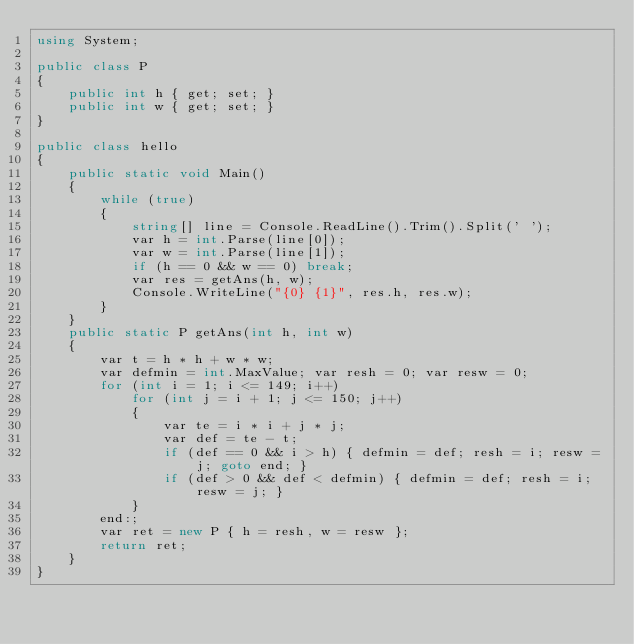Convert code to text. <code><loc_0><loc_0><loc_500><loc_500><_C#_>using System;

public class P
{
    public int h { get; set; }
    public int w { get; set; }
}

public class hello
{
    public static void Main()
    {
        while (true)
        {
            string[] line = Console.ReadLine().Trim().Split(' ');
            var h = int.Parse(line[0]);
            var w = int.Parse(line[1]);
            if (h == 0 && w == 0) break;
            var res = getAns(h, w);
            Console.WriteLine("{0} {1}", res.h, res.w);
        }
    }
    public static P getAns(int h, int w)
    {
        var t = h * h + w * w;
        var defmin = int.MaxValue; var resh = 0; var resw = 0;
        for (int i = 1; i <= 149; i++)
            for (int j = i + 1; j <= 150; j++)
            {
                var te = i * i + j * j;
                var def = te - t;
                if (def == 0 && i > h) { defmin = def; resh = i; resw = j; goto end; }
                if (def > 0 && def < defmin) { defmin = def; resh = i; resw = j; }
            }
        end:;
        var ret = new P { h = resh, w = resw };
        return ret;
    }
}
</code> 